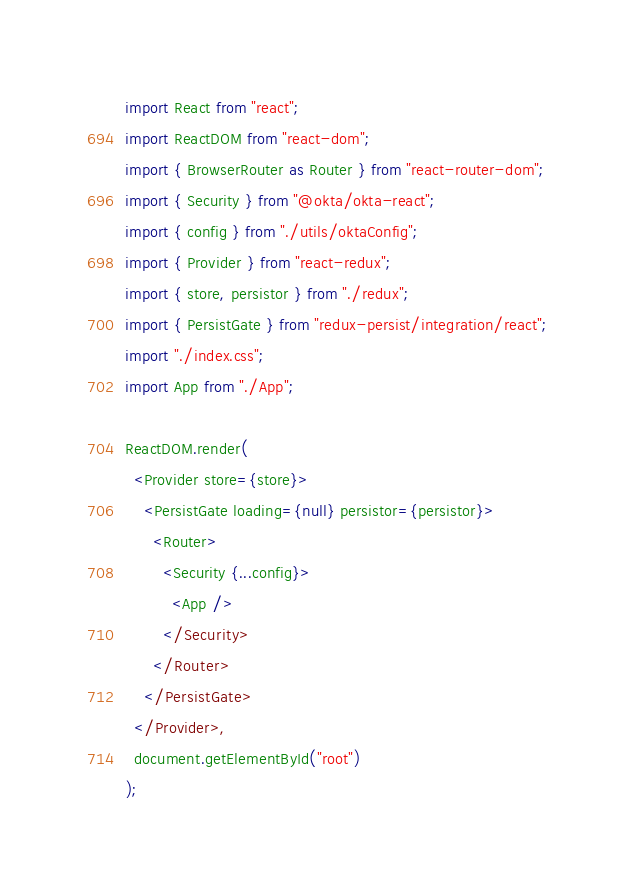Convert code to text. <code><loc_0><loc_0><loc_500><loc_500><_JavaScript_>import React from "react";
import ReactDOM from "react-dom";
import { BrowserRouter as Router } from "react-router-dom";
import { Security } from "@okta/okta-react";
import { config } from "./utils/oktaConfig";
import { Provider } from "react-redux";
import { store, persistor } from "./redux";
import { PersistGate } from "redux-persist/integration/react";
import "./index.css";
import App from "./App";

ReactDOM.render(
  <Provider store={store}>
    <PersistGate loading={null} persistor={persistor}>
      <Router>
        <Security {...config}>
          <App />
        </Security>
      </Router>
    </PersistGate>
  </Provider>,
  document.getElementById("root")
);
</code> 